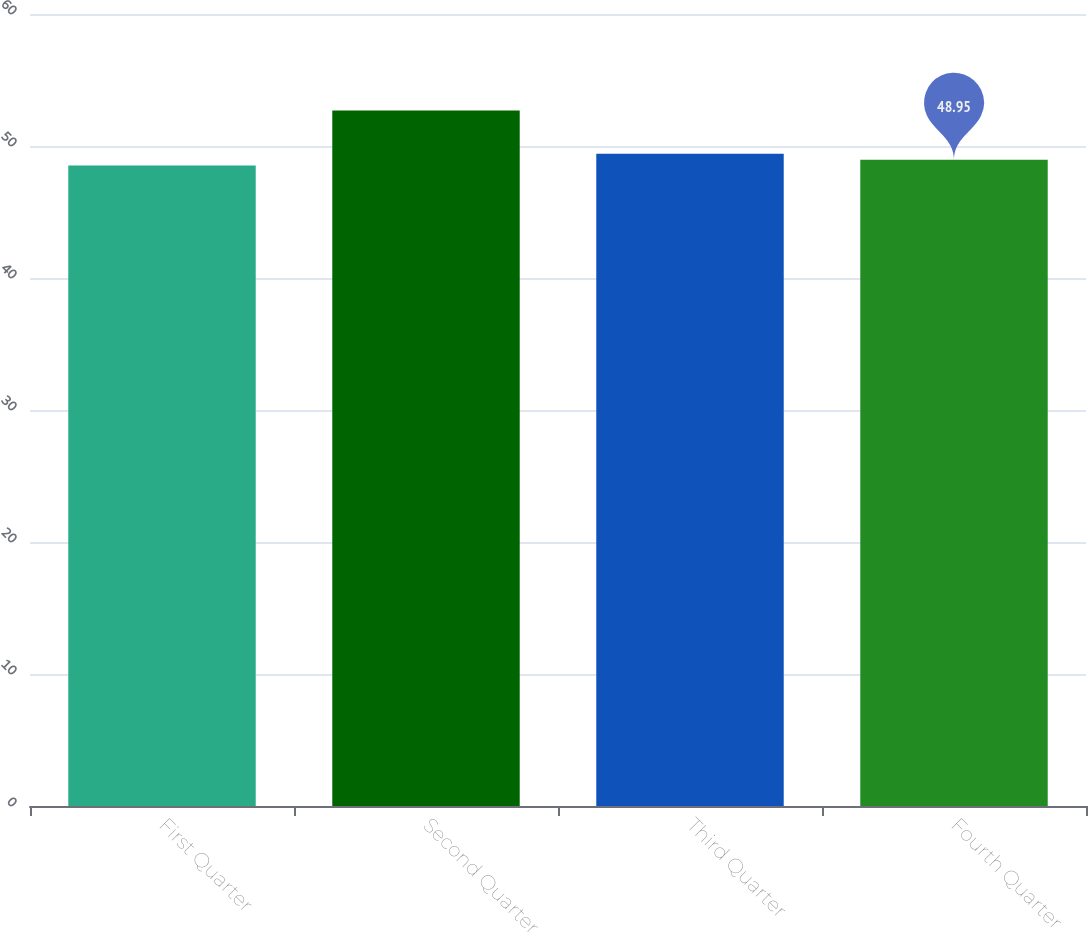Convert chart. <chart><loc_0><loc_0><loc_500><loc_500><bar_chart><fcel>First Quarter<fcel>Second Quarter<fcel>Third Quarter<fcel>Fourth Quarter<nl><fcel>48.53<fcel>52.68<fcel>49.41<fcel>48.95<nl></chart> 